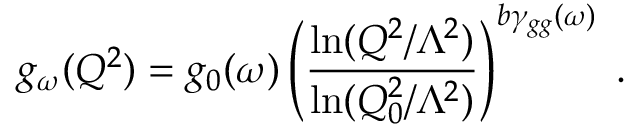Convert formula to latex. <formula><loc_0><loc_0><loc_500><loc_500>g _ { \omega } ( Q ^ { 2 } ) = g _ { 0 } ( \omega ) \left ( { \frac { \ln ( Q ^ { 2 } / \Lambda ^ { 2 } ) } { \ln ( Q _ { 0 } ^ { 2 } / \Lambda ^ { 2 } ) } } \right ) ^ { b \gamma _ { g g } ( \omega ) } \, .</formula> 